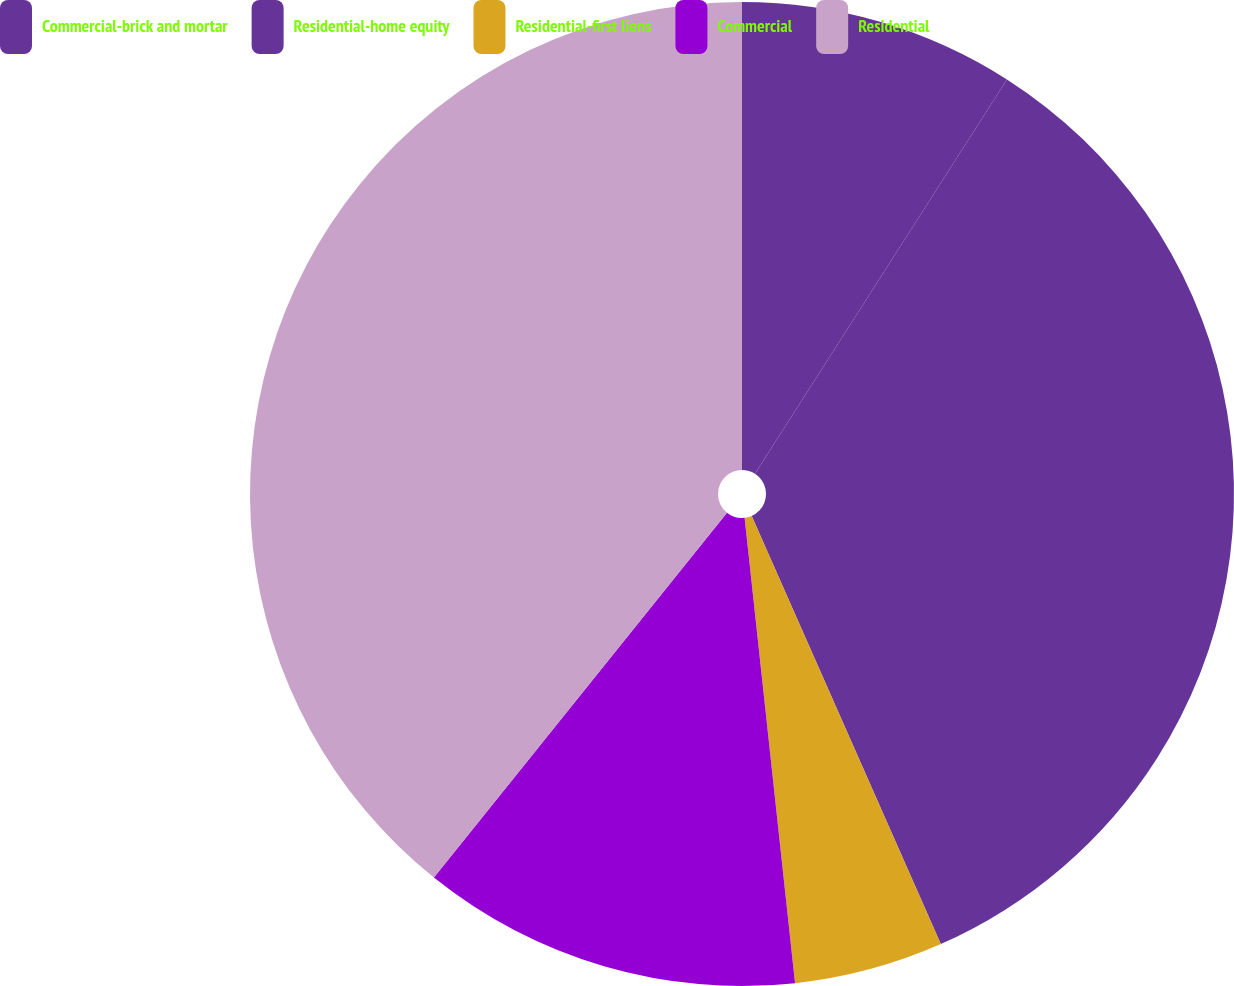Convert chart to OTSL. <chart><loc_0><loc_0><loc_500><loc_500><pie_chart><fcel>Commercial-brick and mortar<fcel>Residential-home equity<fcel>Residential-first liens<fcel>Commercial<fcel>Residential<nl><fcel>9.05%<fcel>34.33%<fcel>4.9%<fcel>12.49%<fcel>39.23%<nl></chart> 